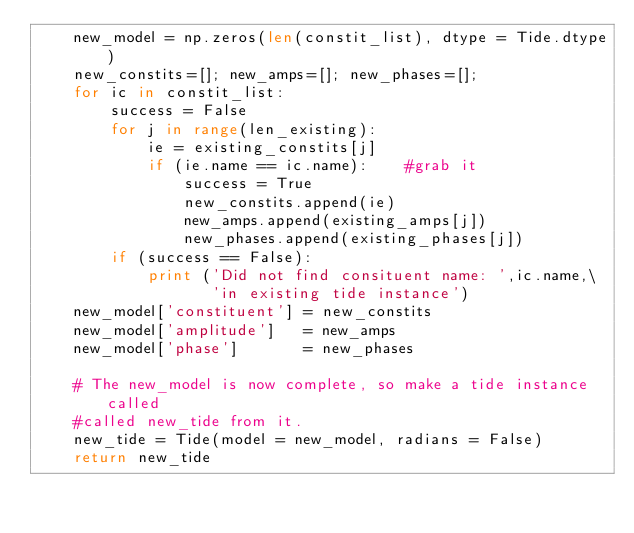Convert code to text. <code><loc_0><loc_0><loc_500><loc_500><_Python_>    new_model = np.zeros(len(constit_list), dtype = Tide.dtype)
    new_constits=[]; new_amps=[]; new_phases=[];
    for ic in constit_list:
        success = False
        for j in range(len_existing):
            ie = existing_constits[j]
            if (ie.name == ic.name):    #grab it
                success = True
                new_constits.append(ie)
                new_amps.append(existing_amps[j])
                new_phases.append(existing_phases[j])
        if (success == False):
            print ('Did not find consituent name: ',ic.name,\
                   'in existing tide instance')
    new_model['constituent'] = new_constits
    new_model['amplitude']   = new_amps
    new_model['phase']       = new_phases

    # The new_model is now complete, so make a tide instance called
    #called new_tide from it.
    new_tide = Tide(model = new_model, radians = False)
    return new_tide
</code> 